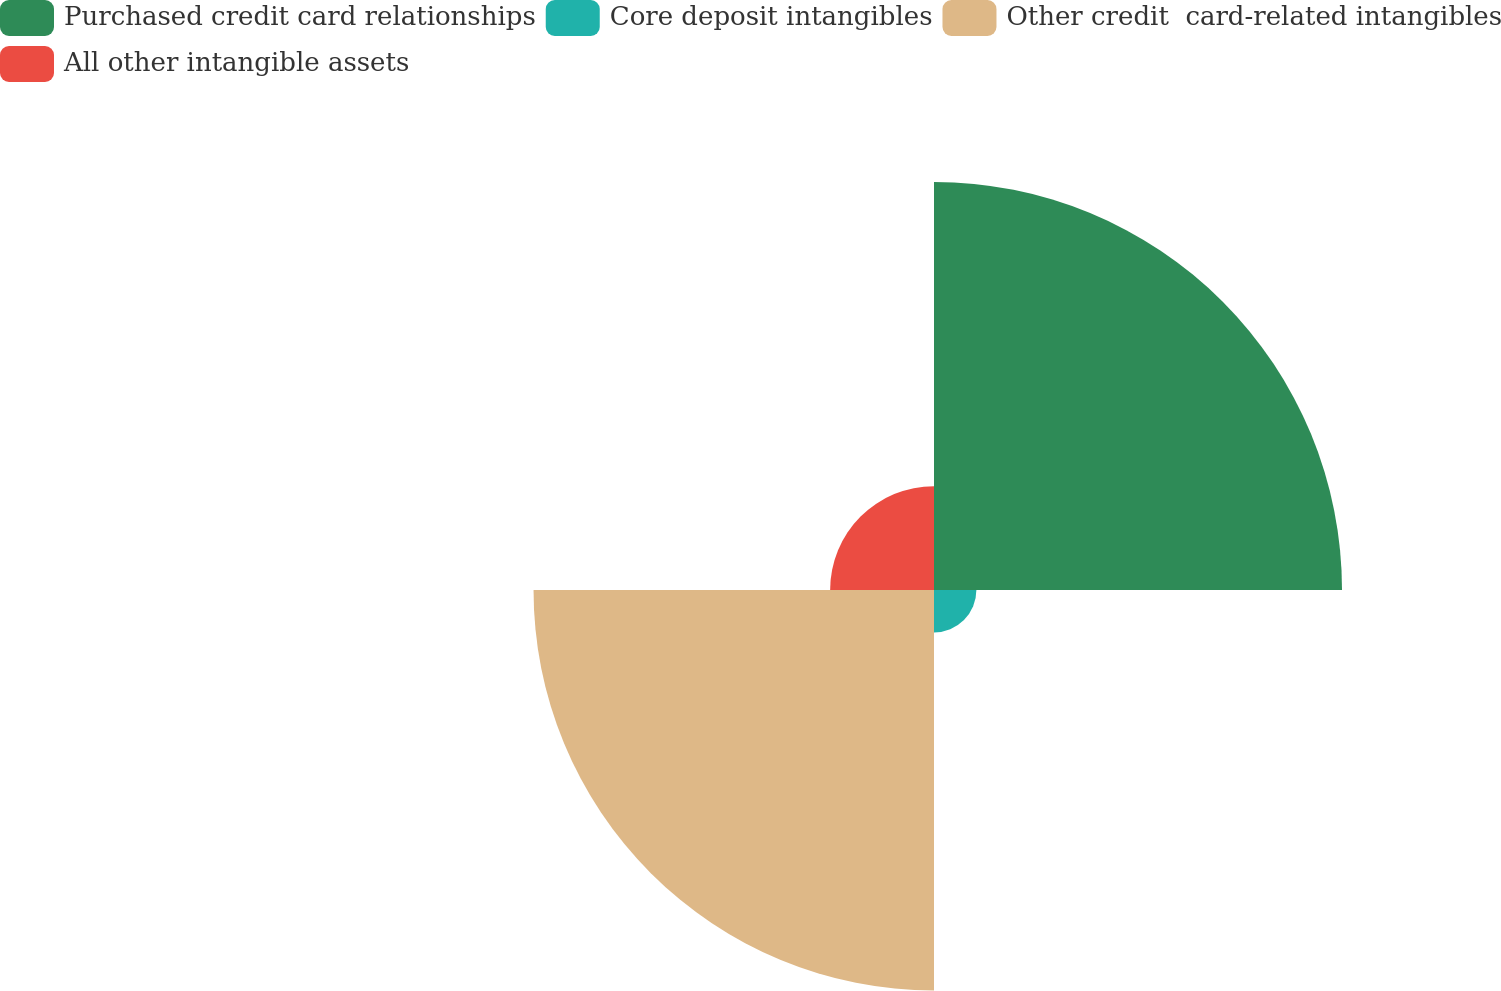Convert chart. <chart><loc_0><loc_0><loc_500><loc_500><pie_chart><fcel>Purchased credit card relationships<fcel>Core deposit intangibles<fcel>Other credit  card-related intangibles<fcel>All other intangible assets<nl><fcel>42.74%<fcel>4.44%<fcel>41.95%<fcel>10.88%<nl></chart> 